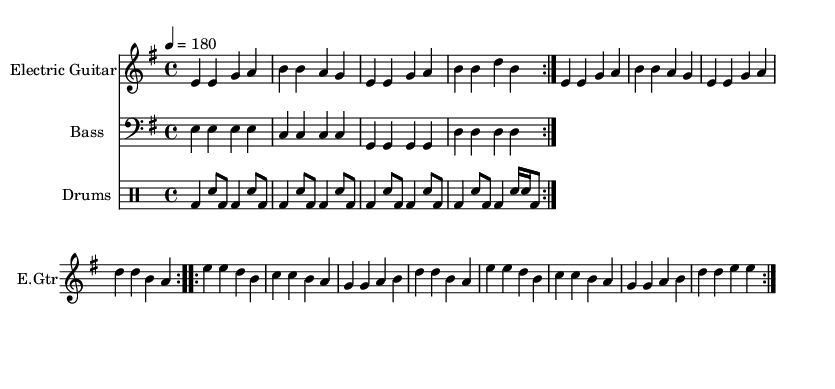What is the key signature of this music? The key signature is E minor, which has one sharp (F#). You can identify the key signature by looking at the beginning of the staff, where the sharps or flats are indicated.
Answer: E minor What is the time signature of this music? The time signature is 4/4. This is found at the beginning of the score, where the note "4" appears above the note "4", indicating four beats per measure.
Answer: 4/4 What is the tempo marking of this music? The tempo marking is 180, indicated with the text "4 = 180" at the beginning. This specifies the number of beats per minute.
Answer: 180 How many times is the verse repeated? The verse is repeated two times, as indicated by the repeated volta markings in the score. The indication "repeat volta 2" shows that the section follows the pattern two times.
Answer: 2 What instrument plays the main melody? The main melody is played by the Electric Guitar, which is the first staff in the score. It uses the relative pitch and rhythms defined in the electricGuitar section.
Answer: Electric Guitar Which line includes lyrics? The lyrics are included in the lines designated for the Electric Guitar. There are two distinct sets of lyrics for the verse and chorus, one below each segment of the guitar music, indicating their associated phrasing.
Answer: Electric Guitar What is the message reflected in the chorus lyrics? The message in the chorus critiques commercialization in sports, as indicated by the lines "Bullseye on greed, we'll shoot it down" and "Punk arrow straight through the corporate crown," suggesting a rebellious stance against corporate influence.
Answer: Critique of commercialization 